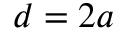<formula> <loc_0><loc_0><loc_500><loc_500>d = 2 a</formula> 